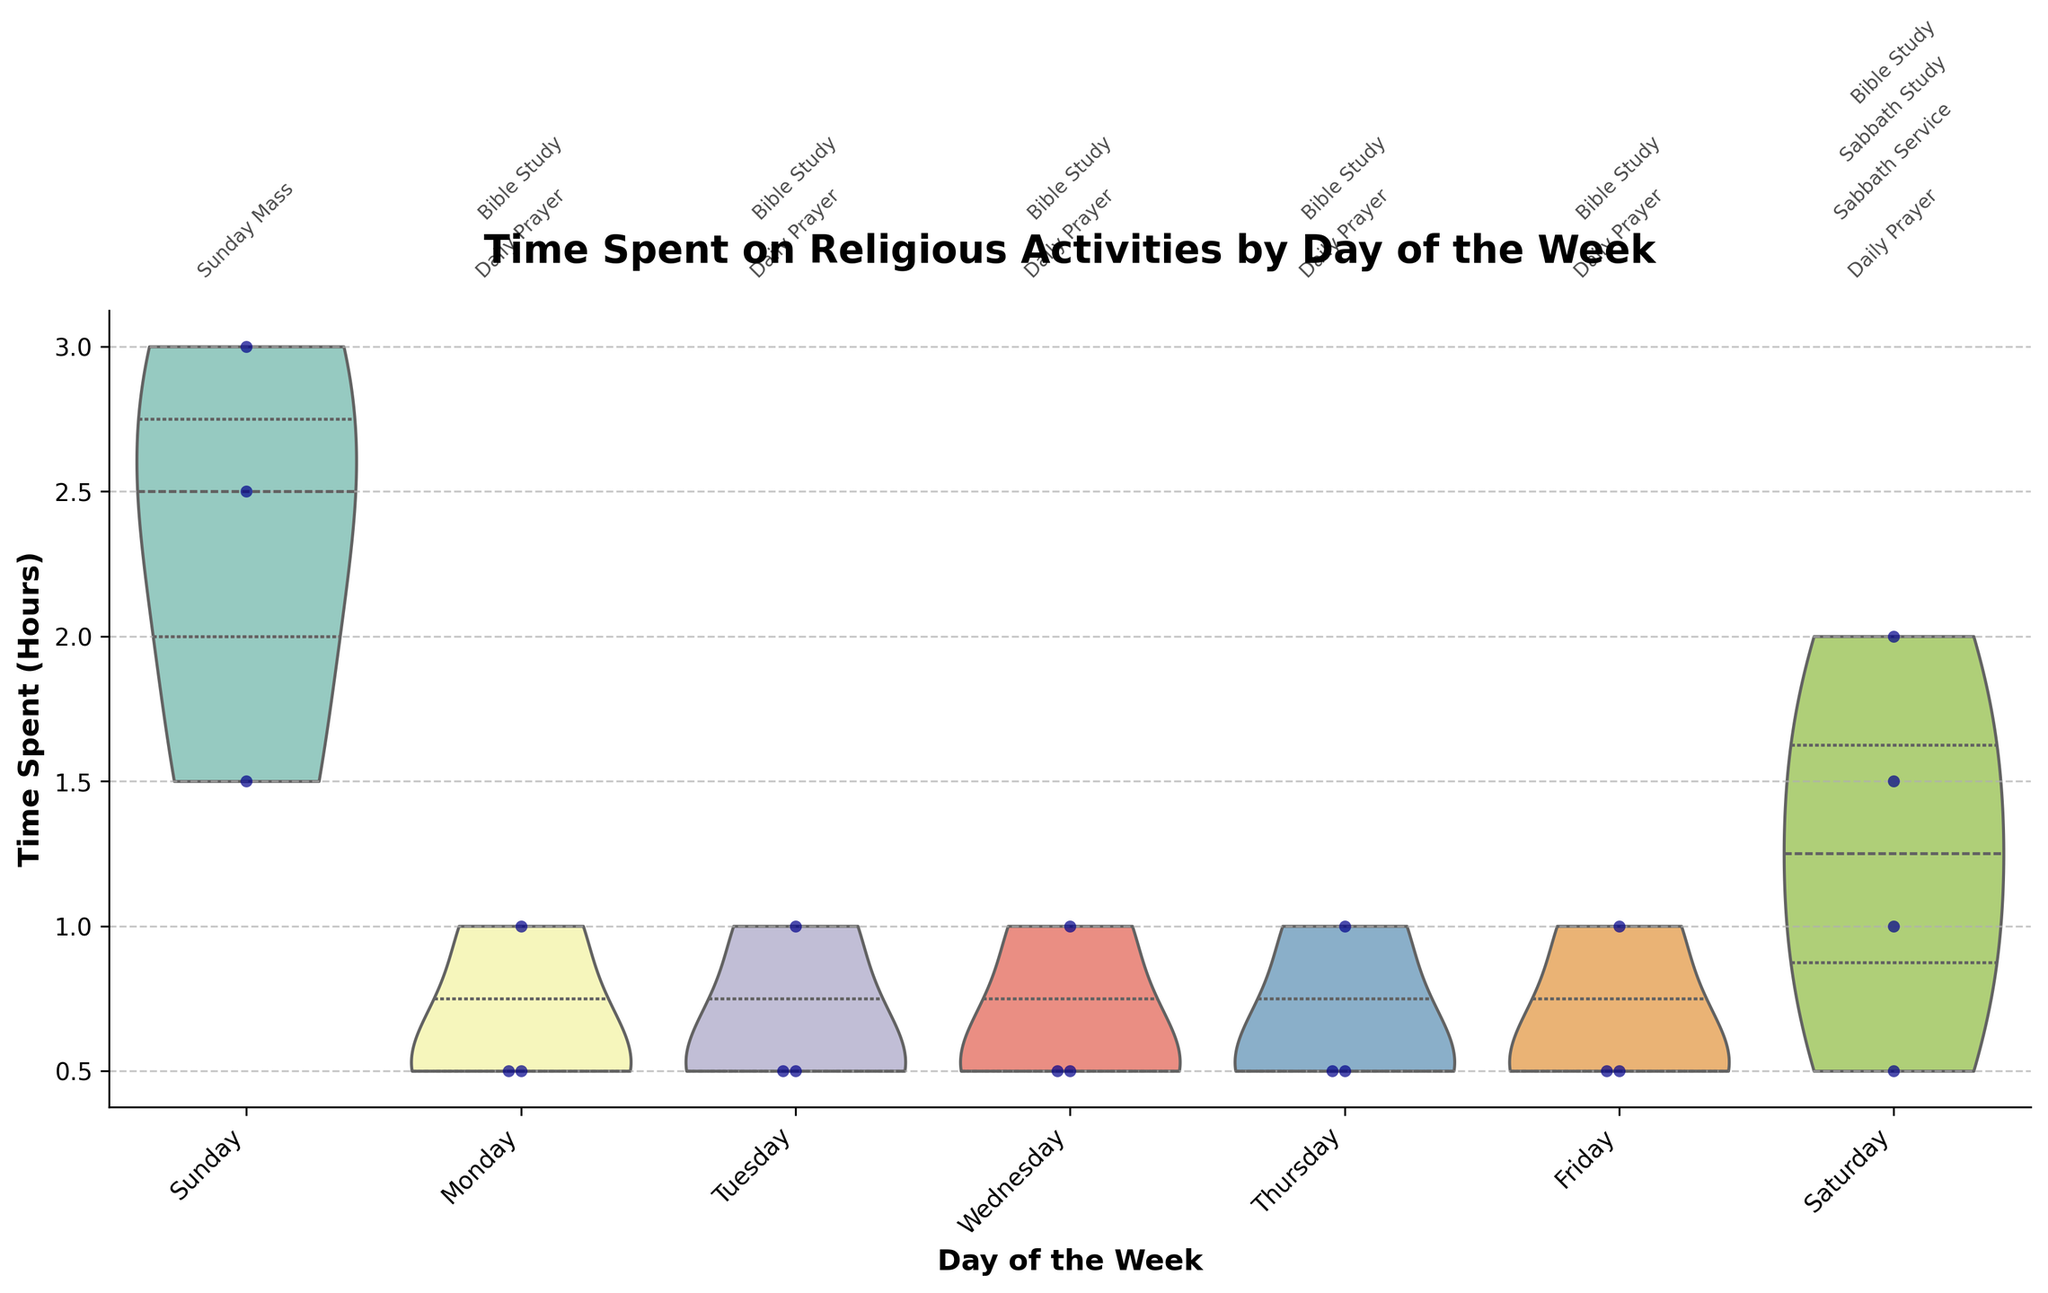What is the title of the plot? The title of the plot is usually positioned at the top to give an overview of the plot's subject matter. It helps understand what the plot is about.
Answer: Time Spent on Religious Activities by Day of the Week What is represented on the x-axis? The x-axis in this plot typically shows the categories that are being compared. Here, it is used to display the days of the week.
Answer: Day of the Week What does the y-axis represent? The y-axis generally shows the numerical measure that is being compared among the categories on the x-axis. Here, it measures the time spent on religious activities in hours.
Answer: Time Spent (Hours) Which day has the highest range of time spent on religious activities? By visually inspecting the widths of the violin plots for each day, the day with the widest violin plot represents the highest range of time spent.
Answer: Sunday On which days is there at least one activity where every individual spends less than 1 hour? By looking at the lower quartile of the violin plots for each day, we can identify the days where the lower part of the plot is below 1 hour.
Answer: Monday, Tuesday, Wednesday, Thursday, Friday, Saturday Which day has the most diversified set of religious activities? By checking the text annotations for the number of different activities listed for each day, we can determine the day with the most varied activities.
Answer: Saturday Compare Monday and Sunday in terms of the median time spent on religious activities. Which day has a higher median? The median is represented by the line inside the violin plot. By comparing the line positions, we can see which day has a higher median value.
Answer: Sunday What is the most common time spent on religious activities on Monday? The most common time spent will be the widest part of the violin plot. On Monday, this appears to be concentrated around a shorter duration.
Answer: 0.5 hours Are there any days where only a single type of activity is recorded? If so, which one(s)? By checking the text annotations for the number of activities per day, we can identify days narrowing down to a single activity.
Answer: Monday, Tuesday, Wednesday, Thursday, Friday Which individual has the highest recorded single time spent on religious activities and on what day? By observing the swarm points outside the violins, the highest point represents the highest recorded single time.
Answer: Michael Brown on Saturday 